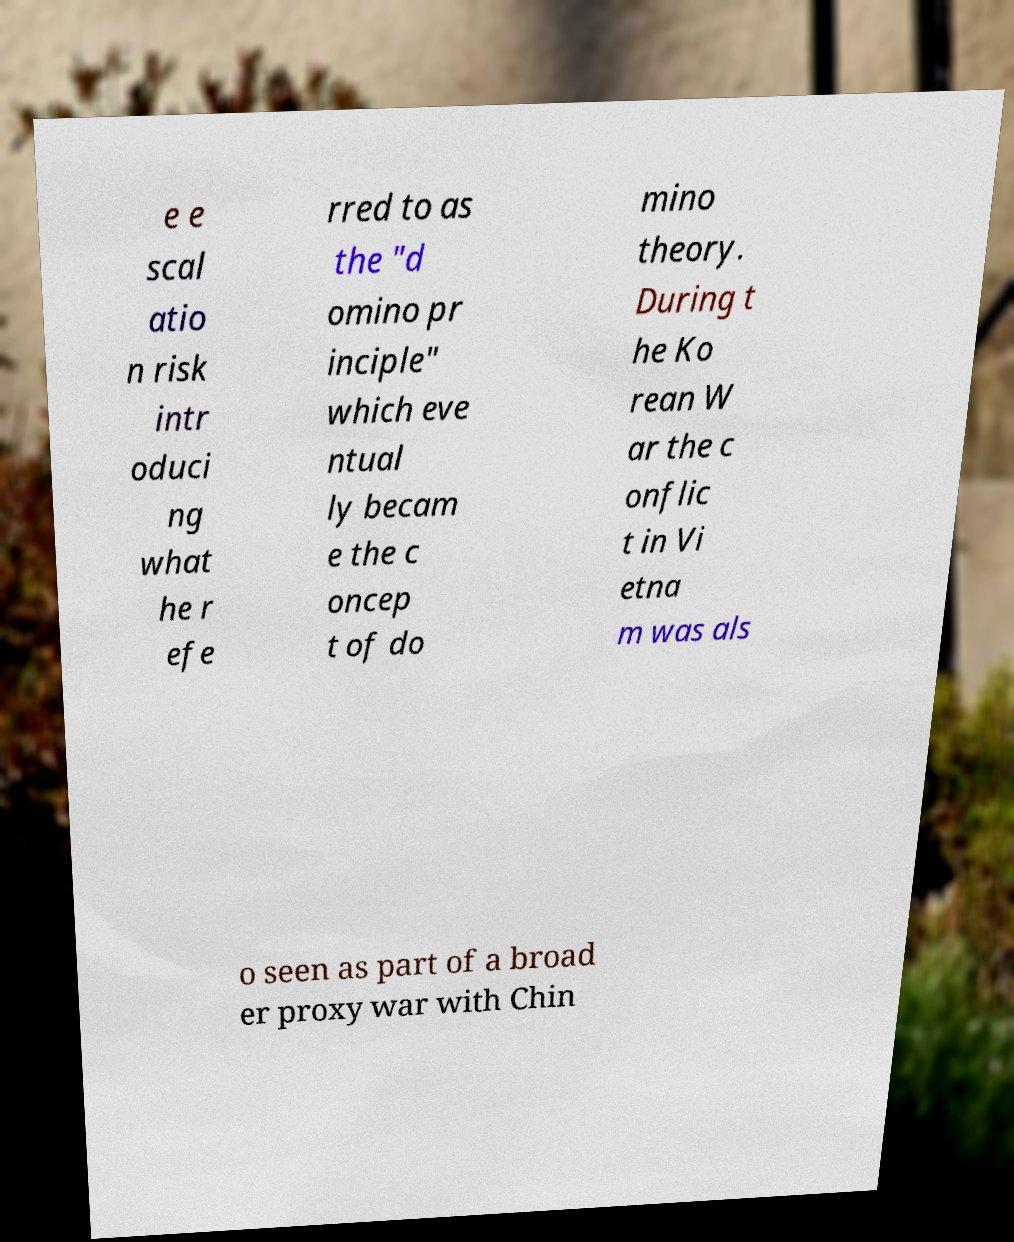Could you assist in decoding the text presented in this image and type it out clearly? e e scal atio n risk intr oduci ng what he r efe rred to as the "d omino pr inciple" which eve ntual ly becam e the c oncep t of do mino theory. During t he Ko rean W ar the c onflic t in Vi etna m was als o seen as part of a broad er proxy war with Chin 